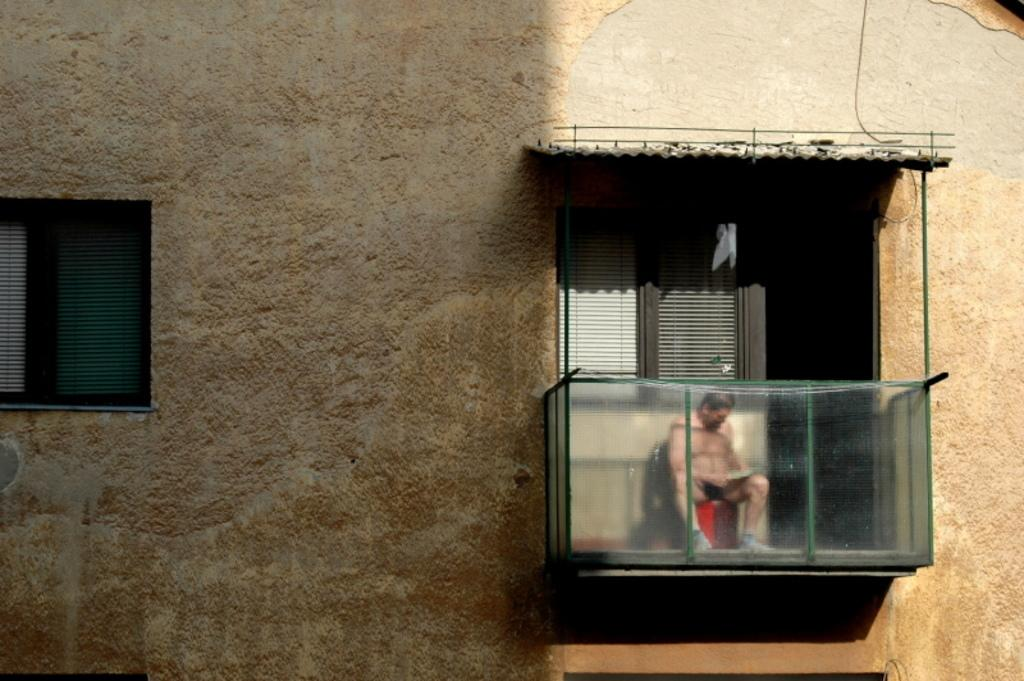What type of structure is visible in the image? There is a building wall in the image. What architectural feature can be seen on the wall? There is a window in the image. What other feature is present on the wall? There is a balcony door with a glass railing in the image. Can you describe the person in the image? A person is sitting near the balcony door. What type of cork is being used to secure the jail cell in the image? There is no jail or cork present in the image; it features a building wall with a window and balcony door. How many nails can be seen holding the balcony door in place in the image? There are no nails visible in the image; the balcony door has a glass railing. 